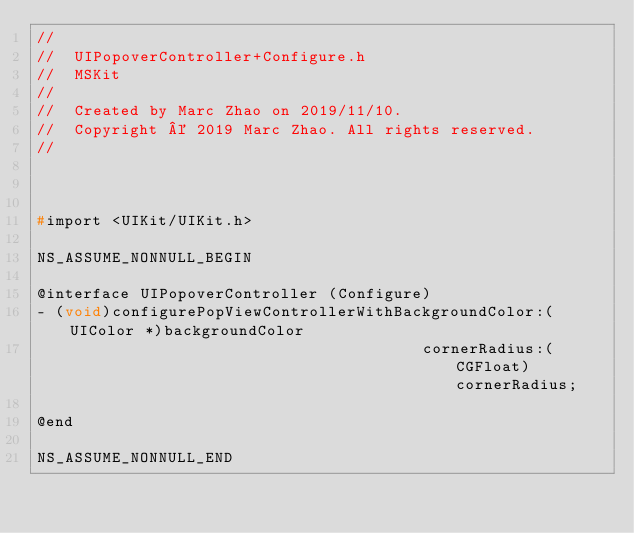<code> <loc_0><loc_0><loc_500><loc_500><_C_>//
//  UIPopoverController+Configure.h
//  MSKit
//
//  Created by Marc Zhao on 2019/11/10.
//  Copyright © 2019 Marc Zhao. All rights reserved.
//



#import <UIKit/UIKit.h>

NS_ASSUME_NONNULL_BEGIN

@interface UIPopoverController (Configure)
- (void)configurePopViewControllerWithBackgroundColor:(UIColor *)backgroundColor
                                         cornerRadius:(CGFloat)cornerRadius;

@end

NS_ASSUME_NONNULL_END
</code> 